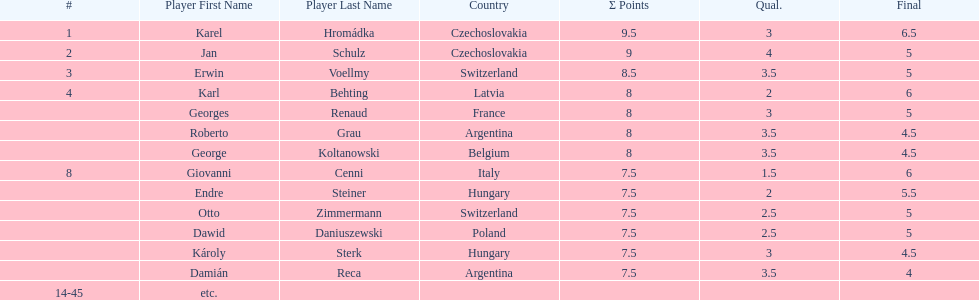How many players had a 8 points? 4. Would you mind parsing the complete table? {'header': ['#', 'Player First Name', 'Player Last Name', 'Country', 'Σ Points', 'Qual.', 'Final'], 'rows': [['1', 'Karel', 'Hromádka', 'Czechoslovakia', '9.5', '3', '6.5'], ['2', 'Jan', 'Schulz', 'Czechoslovakia', '9', '4', '5'], ['3', 'Erwin', 'Voellmy', 'Switzerland', '8.5', '3.5', '5'], ['4', 'Karl', 'Behting', 'Latvia', '8', '2', '6'], ['', 'Georges', 'Renaud', 'France', '8', '3', '5'], ['', 'Roberto', 'Grau', 'Argentina', '8', '3.5', '4.5'], ['', 'George', 'Koltanowski', 'Belgium', '8', '3.5', '4.5'], ['8', 'Giovanni', 'Cenni', 'Italy', '7.5', '1.5', '6'], ['', 'Endre', 'Steiner', 'Hungary', '7.5', '2', '5.5'], ['', 'Otto', 'Zimmermann', 'Switzerland', '7.5', '2.5', '5'], ['', 'Dawid', 'Daniuszewski', 'Poland', '7.5', '2.5', '5'], ['', 'Károly', 'Sterk', 'Hungary', '7.5', '3', '4.5'], ['', 'Damián', 'Reca', 'Argentina', '7.5', '3.5', '4'], ['14-45', 'etc.', '', '', '', '', '']]} 